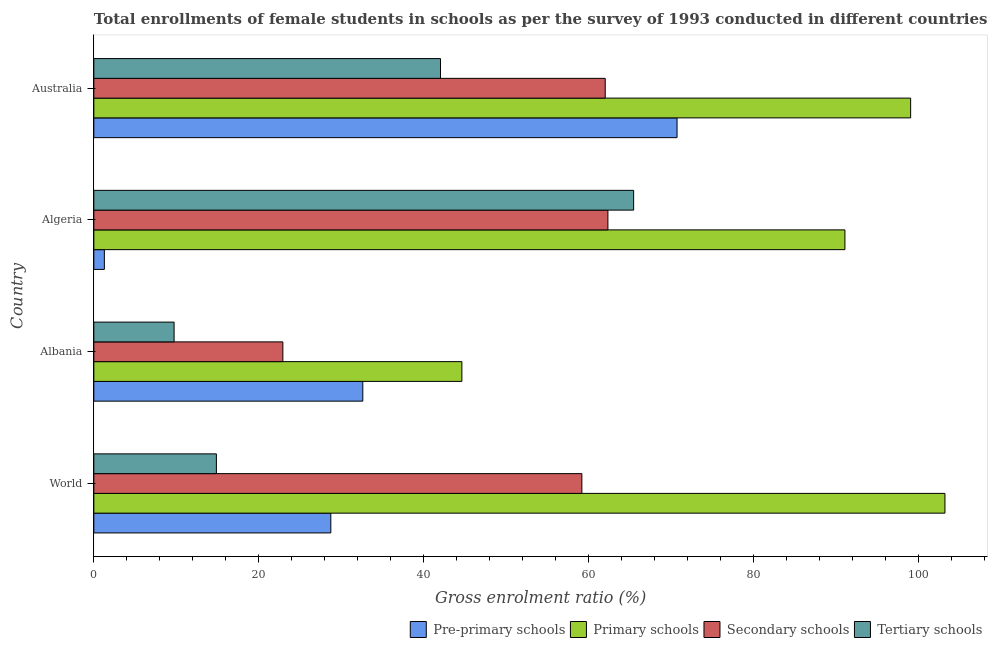How many groups of bars are there?
Keep it short and to the point. 4. Are the number of bars per tick equal to the number of legend labels?
Your response must be concise. Yes. How many bars are there on the 2nd tick from the top?
Provide a short and direct response. 4. What is the label of the 2nd group of bars from the top?
Keep it short and to the point. Algeria. What is the gross enrolment ratio(female) in secondary schools in Australia?
Provide a succinct answer. 62. Across all countries, what is the maximum gross enrolment ratio(female) in secondary schools?
Your answer should be very brief. 62.33. Across all countries, what is the minimum gross enrolment ratio(female) in primary schools?
Your answer should be very brief. 44.62. In which country was the gross enrolment ratio(female) in pre-primary schools maximum?
Offer a very short reply. Australia. In which country was the gross enrolment ratio(female) in tertiary schools minimum?
Your response must be concise. Albania. What is the total gross enrolment ratio(female) in secondary schools in the graph?
Provide a short and direct response. 206.42. What is the difference between the gross enrolment ratio(female) in secondary schools in Albania and that in Australia?
Keep it short and to the point. -39.08. What is the difference between the gross enrolment ratio(female) in tertiary schools in World and the gross enrolment ratio(female) in secondary schools in Albania?
Offer a very short reply. -8.06. What is the average gross enrolment ratio(female) in secondary schools per country?
Your response must be concise. 51.6. What is the ratio of the gross enrolment ratio(female) in tertiary schools in Algeria to that in World?
Give a very brief answer. 4.4. Is the difference between the gross enrolment ratio(female) in primary schools in Algeria and Australia greater than the difference between the gross enrolment ratio(female) in pre-primary schools in Algeria and Australia?
Give a very brief answer. Yes. What is the difference between the highest and the second highest gross enrolment ratio(female) in tertiary schools?
Ensure brevity in your answer.  23.42. What is the difference between the highest and the lowest gross enrolment ratio(female) in secondary schools?
Your response must be concise. 39.41. Is the sum of the gross enrolment ratio(female) in tertiary schools in Algeria and World greater than the maximum gross enrolment ratio(female) in pre-primary schools across all countries?
Offer a terse response. Yes. Is it the case that in every country, the sum of the gross enrolment ratio(female) in primary schools and gross enrolment ratio(female) in secondary schools is greater than the sum of gross enrolment ratio(female) in pre-primary schools and gross enrolment ratio(female) in tertiary schools?
Keep it short and to the point. No. What does the 1st bar from the top in World represents?
Your answer should be compact. Tertiary schools. What does the 2nd bar from the bottom in Albania represents?
Provide a short and direct response. Primary schools. How many bars are there?
Keep it short and to the point. 16. Are all the bars in the graph horizontal?
Keep it short and to the point. Yes. What is the difference between two consecutive major ticks on the X-axis?
Make the answer very short. 20. Are the values on the major ticks of X-axis written in scientific E-notation?
Offer a very short reply. No. Does the graph contain grids?
Make the answer very short. No. How many legend labels are there?
Provide a short and direct response. 4. How are the legend labels stacked?
Your answer should be very brief. Horizontal. What is the title of the graph?
Your response must be concise. Total enrollments of female students in schools as per the survey of 1993 conducted in different countries. What is the label or title of the X-axis?
Provide a short and direct response. Gross enrolment ratio (%). What is the label or title of the Y-axis?
Offer a terse response. Country. What is the Gross enrolment ratio (%) in Pre-primary schools in World?
Make the answer very short. 28.73. What is the Gross enrolment ratio (%) in Primary schools in World?
Ensure brevity in your answer.  103.19. What is the Gross enrolment ratio (%) in Secondary schools in World?
Keep it short and to the point. 59.17. What is the Gross enrolment ratio (%) of Tertiary schools in World?
Ensure brevity in your answer.  14.86. What is the Gross enrolment ratio (%) in Pre-primary schools in Albania?
Ensure brevity in your answer.  32.61. What is the Gross enrolment ratio (%) of Primary schools in Albania?
Offer a terse response. 44.62. What is the Gross enrolment ratio (%) of Secondary schools in Albania?
Offer a very short reply. 22.92. What is the Gross enrolment ratio (%) of Tertiary schools in Albania?
Provide a short and direct response. 9.73. What is the Gross enrolment ratio (%) in Pre-primary schools in Algeria?
Your response must be concise. 1.28. What is the Gross enrolment ratio (%) of Primary schools in Algeria?
Ensure brevity in your answer.  91.06. What is the Gross enrolment ratio (%) of Secondary schools in Algeria?
Provide a short and direct response. 62.33. What is the Gross enrolment ratio (%) in Tertiary schools in Algeria?
Make the answer very short. 65.45. What is the Gross enrolment ratio (%) in Pre-primary schools in Australia?
Your answer should be compact. 70.71. What is the Gross enrolment ratio (%) in Primary schools in Australia?
Make the answer very short. 99.03. What is the Gross enrolment ratio (%) of Secondary schools in Australia?
Provide a short and direct response. 62. What is the Gross enrolment ratio (%) in Tertiary schools in Australia?
Your answer should be very brief. 42.03. Across all countries, what is the maximum Gross enrolment ratio (%) of Pre-primary schools?
Offer a very short reply. 70.71. Across all countries, what is the maximum Gross enrolment ratio (%) in Primary schools?
Give a very brief answer. 103.19. Across all countries, what is the maximum Gross enrolment ratio (%) in Secondary schools?
Offer a terse response. 62.33. Across all countries, what is the maximum Gross enrolment ratio (%) in Tertiary schools?
Your answer should be very brief. 65.45. Across all countries, what is the minimum Gross enrolment ratio (%) of Pre-primary schools?
Your response must be concise. 1.28. Across all countries, what is the minimum Gross enrolment ratio (%) in Primary schools?
Keep it short and to the point. 44.62. Across all countries, what is the minimum Gross enrolment ratio (%) of Secondary schools?
Make the answer very short. 22.92. Across all countries, what is the minimum Gross enrolment ratio (%) of Tertiary schools?
Give a very brief answer. 9.73. What is the total Gross enrolment ratio (%) in Pre-primary schools in the graph?
Provide a short and direct response. 133.33. What is the total Gross enrolment ratio (%) of Primary schools in the graph?
Offer a very short reply. 337.91. What is the total Gross enrolment ratio (%) in Secondary schools in the graph?
Provide a short and direct response. 206.42. What is the total Gross enrolment ratio (%) of Tertiary schools in the graph?
Offer a terse response. 132.07. What is the difference between the Gross enrolment ratio (%) in Pre-primary schools in World and that in Albania?
Offer a very short reply. -3.88. What is the difference between the Gross enrolment ratio (%) of Primary schools in World and that in Albania?
Ensure brevity in your answer.  58.57. What is the difference between the Gross enrolment ratio (%) of Secondary schools in World and that in Albania?
Provide a succinct answer. 36.25. What is the difference between the Gross enrolment ratio (%) in Tertiary schools in World and that in Albania?
Make the answer very short. 5.13. What is the difference between the Gross enrolment ratio (%) of Pre-primary schools in World and that in Algeria?
Give a very brief answer. 27.45. What is the difference between the Gross enrolment ratio (%) in Primary schools in World and that in Algeria?
Your response must be concise. 12.13. What is the difference between the Gross enrolment ratio (%) in Secondary schools in World and that in Algeria?
Give a very brief answer. -3.16. What is the difference between the Gross enrolment ratio (%) in Tertiary schools in World and that in Algeria?
Give a very brief answer. -50.59. What is the difference between the Gross enrolment ratio (%) in Pre-primary schools in World and that in Australia?
Your answer should be compact. -41.98. What is the difference between the Gross enrolment ratio (%) of Primary schools in World and that in Australia?
Offer a very short reply. 4.16. What is the difference between the Gross enrolment ratio (%) in Secondary schools in World and that in Australia?
Ensure brevity in your answer.  -2.83. What is the difference between the Gross enrolment ratio (%) in Tertiary schools in World and that in Australia?
Give a very brief answer. -27.17. What is the difference between the Gross enrolment ratio (%) in Pre-primary schools in Albania and that in Algeria?
Keep it short and to the point. 31.33. What is the difference between the Gross enrolment ratio (%) in Primary schools in Albania and that in Algeria?
Offer a very short reply. -46.44. What is the difference between the Gross enrolment ratio (%) in Secondary schools in Albania and that in Algeria?
Keep it short and to the point. -39.41. What is the difference between the Gross enrolment ratio (%) in Tertiary schools in Albania and that in Algeria?
Offer a very short reply. -55.72. What is the difference between the Gross enrolment ratio (%) of Pre-primary schools in Albania and that in Australia?
Your answer should be compact. -38.1. What is the difference between the Gross enrolment ratio (%) of Primary schools in Albania and that in Australia?
Your response must be concise. -54.41. What is the difference between the Gross enrolment ratio (%) of Secondary schools in Albania and that in Australia?
Make the answer very short. -39.08. What is the difference between the Gross enrolment ratio (%) of Tertiary schools in Albania and that in Australia?
Your answer should be very brief. -32.3. What is the difference between the Gross enrolment ratio (%) of Pre-primary schools in Algeria and that in Australia?
Provide a short and direct response. -69.43. What is the difference between the Gross enrolment ratio (%) of Primary schools in Algeria and that in Australia?
Offer a terse response. -7.97. What is the difference between the Gross enrolment ratio (%) of Secondary schools in Algeria and that in Australia?
Give a very brief answer. 0.33. What is the difference between the Gross enrolment ratio (%) in Tertiary schools in Algeria and that in Australia?
Ensure brevity in your answer.  23.42. What is the difference between the Gross enrolment ratio (%) in Pre-primary schools in World and the Gross enrolment ratio (%) in Primary schools in Albania?
Your answer should be very brief. -15.89. What is the difference between the Gross enrolment ratio (%) of Pre-primary schools in World and the Gross enrolment ratio (%) of Secondary schools in Albania?
Provide a succinct answer. 5.81. What is the difference between the Gross enrolment ratio (%) in Pre-primary schools in World and the Gross enrolment ratio (%) in Tertiary schools in Albania?
Give a very brief answer. 19. What is the difference between the Gross enrolment ratio (%) in Primary schools in World and the Gross enrolment ratio (%) in Secondary schools in Albania?
Your response must be concise. 80.27. What is the difference between the Gross enrolment ratio (%) in Primary schools in World and the Gross enrolment ratio (%) in Tertiary schools in Albania?
Your answer should be very brief. 93.46. What is the difference between the Gross enrolment ratio (%) of Secondary schools in World and the Gross enrolment ratio (%) of Tertiary schools in Albania?
Provide a short and direct response. 49.44. What is the difference between the Gross enrolment ratio (%) of Pre-primary schools in World and the Gross enrolment ratio (%) of Primary schools in Algeria?
Ensure brevity in your answer.  -62.33. What is the difference between the Gross enrolment ratio (%) of Pre-primary schools in World and the Gross enrolment ratio (%) of Secondary schools in Algeria?
Offer a terse response. -33.59. What is the difference between the Gross enrolment ratio (%) in Pre-primary schools in World and the Gross enrolment ratio (%) in Tertiary schools in Algeria?
Provide a succinct answer. -36.71. What is the difference between the Gross enrolment ratio (%) in Primary schools in World and the Gross enrolment ratio (%) in Secondary schools in Algeria?
Provide a short and direct response. 40.86. What is the difference between the Gross enrolment ratio (%) of Primary schools in World and the Gross enrolment ratio (%) of Tertiary schools in Algeria?
Offer a terse response. 37.74. What is the difference between the Gross enrolment ratio (%) in Secondary schools in World and the Gross enrolment ratio (%) in Tertiary schools in Algeria?
Make the answer very short. -6.28. What is the difference between the Gross enrolment ratio (%) of Pre-primary schools in World and the Gross enrolment ratio (%) of Primary schools in Australia?
Provide a succinct answer. -70.3. What is the difference between the Gross enrolment ratio (%) of Pre-primary schools in World and the Gross enrolment ratio (%) of Secondary schools in Australia?
Ensure brevity in your answer.  -33.27. What is the difference between the Gross enrolment ratio (%) of Pre-primary schools in World and the Gross enrolment ratio (%) of Tertiary schools in Australia?
Your answer should be very brief. -13.3. What is the difference between the Gross enrolment ratio (%) of Primary schools in World and the Gross enrolment ratio (%) of Secondary schools in Australia?
Give a very brief answer. 41.19. What is the difference between the Gross enrolment ratio (%) of Primary schools in World and the Gross enrolment ratio (%) of Tertiary schools in Australia?
Provide a short and direct response. 61.16. What is the difference between the Gross enrolment ratio (%) of Secondary schools in World and the Gross enrolment ratio (%) of Tertiary schools in Australia?
Your answer should be very brief. 17.14. What is the difference between the Gross enrolment ratio (%) of Pre-primary schools in Albania and the Gross enrolment ratio (%) of Primary schools in Algeria?
Give a very brief answer. -58.45. What is the difference between the Gross enrolment ratio (%) of Pre-primary schools in Albania and the Gross enrolment ratio (%) of Secondary schools in Algeria?
Your answer should be compact. -29.72. What is the difference between the Gross enrolment ratio (%) of Pre-primary schools in Albania and the Gross enrolment ratio (%) of Tertiary schools in Algeria?
Provide a succinct answer. -32.84. What is the difference between the Gross enrolment ratio (%) in Primary schools in Albania and the Gross enrolment ratio (%) in Secondary schools in Algeria?
Your answer should be very brief. -17.7. What is the difference between the Gross enrolment ratio (%) of Primary schools in Albania and the Gross enrolment ratio (%) of Tertiary schools in Algeria?
Your answer should be compact. -20.82. What is the difference between the Gross enrolment ratio (%) in Secondary schools in Albania and the Gross enrolment ratio (%) in Tertiary schools in Algeria?
Make the answer very short. -42.53. What is the difference between the Gross enrolment ratio (%) of Pre-primary schools in Albania and the Gross enrolment ratio (%) of Primary schools in Australia?
Offer a terse response. -66.42. What is the difference between the Gross enrolment ratio (%) of Pre-primary schools in Albania and the Gross enrolment ratio (%) of Secondary schools in Australia?
Your answer should be very brief. -29.39. What is the difference between the Gross enrolment ratio (%) of Pre-primary schools in Albania and the Gross enrolment ratio (%) of Tertiary schools in Australia?
Provide a short and direct response. -9.42. What is the difference between the Gross enrolment ratio (%) of Primary schools in Albania and the Gross enrolment ratio (%) of Secondary schools in Australia?
Keep it short and to the point. -17.38. What is the difference between the Gross enrolment ratio (%) of Primary schools in Albania and the Gross enrolment ratio (%) of Tertiary schools in Australia?
Provide a short and direct response. 2.59. What is the difference between the Gross enrolment ratio (%) in Secondary schools in Albania and the Gross enrolment ratio (%) in Tertiary schools in Australia?
Provide a succinct answer. -19.11. What is the difference between the Gross enrolment ratio (%) in Pre-primary schools in Algeria and the Gross enrolment ratio (%) in Primary schools in Australia?
Keep it short and to the point. -97.75. What is the difference between the Gross enrolment ratio (%) of Pre-primary schools in Algeria and the Gross enrolment ratio (%) of Secondary schools in Australia?
Your response must be concise. -60.72. What is the difference between the Gross enrolment ratio (%) in Pre-primary schools in Algeria and the Gross enrolment ratio (%) in Tertiary schools in Australia?
Make the answer very short. -40.75. What is the difference between the Gross enrolment ratio (%) of Primary schools in Algeria and the Gross enrolment ratio (%) of Secondary schools in Australia?
Provide a succinct answer. 29.06. What is the difference between the Gross enrolment ratio (%) of Primary schools in Algeria and the Gross enrolment ratio (%) of Tertiary schools in Australia?
Give a very brief answer. 49.03. What is the difference between the Gross enrolment ratio (%) in Secondary schools in Algeria and the Gross enrolment ratio (%) in Tertiary schools in Australia?
Make the answer very short. 20.3. What is the average Gross enrolment ratio (%) in Pre-primary schools per country?
Give a very brief answer. 33.33. What is the average Gross enrolment ratio (%) in Primary schools per country?
Provide a succinct answer. 84.48. What is the average Gross enrolment ratio (%) of Secondary schools per country?
Your answer should be very brief. 51.6. What is the average Gross enrolment ratio (%) of Tertiary schools per country?
Give a very brief answer. 33.02. What is the difference between the Gross enrolment ratio (%) in Pre-primary schools and Gross enrolment ratio (%) in Primary schools in World?
Provide a short and direct response. -74.46. What is the difference between the Gross enrolment ratio (%) of Pre-primary schools and Gross enrolment ratio (%) of Secondary schools in World?
Provide a succinct answer. -30.44. What is the difference between the Gross enrolment ratio (%) of Pre-primary schools and Gross enrolment ratio (%) of Tertiary schools in World?
Give a very brief answer. 13.87. What is the difference between the Gross enrolment ratio (%) in Primary schools and Gross enrolment ratio (%) in Secondary schools in World?
Your answer should be very brief. 44.02. What is the difference between the Gross enrolment ratio (%) in Primary schools and Gross enrolment ratio (%) in Tertiary schools in World?
Your response must be concise. 88.33. What is the difference between the Gross enrolment ratio (%) in Secondary schools and Gross enrolment ratio (%) in Tertiary schools in World?
Keep it short and to the point. 44.31. What is the difference between the Gross enrolment ratio (%) of Pre-primary schools and Gross enrolment ratio (%) of Primary schools in Albania?
Ensure brevity in your answer.  -12.01. What is the difference between the Gross enrolment ratio (%) of Pre-primary schools and Gross enrolment ratio (%) of Secondary schools in Albania?
Your answer should be very brief. 9.69. What is the difference between the Gross enrolment ratio (%) in Pre-primary schools and Gross enrolment ratio (%) in Tertiary schools in Albania?
Give a very brief answer. 22.88. What is the difference between the Gross enrolment ratio (%) in Primary schools and Gross enrolment ratio (%) in Secondary schools in Albania?
Provide a short and direct response. 21.7. What is the difference between the Gross enrolment ratio (%) of Primary schools and Gross enrolment ratio (%) of Tertiary schools in Albania?
Offer a terse response. 34.89. What is the difference between the Gross enrolment ratio (%) in Secondary schools and Gross enrolment ratio (%) in Tertiary schools in Albania?
Keep it short and to the point. 13.19. What is the difference between the Gross enrolment ratio (%) of Pre-primary schools and Gross enrolment ratio (%) of Primary schools in Algeria?
Your answer should be compact. -89.79. What is the difference between the Gross enrolment ratio (%) in Pre-primary schools and Gross enrolment ratio (%) in Secondary schools in Algeria?
Your answer should be compact. -61.05. What is the difference between the Gross enrolment ratio (%) in Pre-primary schools and Gross enrolment ratio (%) in Tertiary schools in Algeria?
Make the answer very short. -64.17. What is the difference between the Gross enrolment ratio (%) in Primary schools and Gross enrolment ratio (%) in Secondary schools in Algeria?
Provide a short and direct response. 28.74. What is the difference between the Gross enrolment ratio (%) of Primary schools and Gross enrolment ratio (%) of Tertiary schools in Algeria?
Your answer should be very brief. 25.62. What is the difference between the Gross enrolment ratio (%) in Secondary schools and Gross enrolment ratio (%) in Tertiary schools in Algeria?
Your answer should be very brief. -3.12. What is the difference between the Gross enrolment ratio (%) of Pre-primary schools and Gross enrolment ratio (%) of Primary schools in Australia?
Ensure brevity in your answer.  -28.32. What is the difference between the Gross enrolment ratio (%) of Pre-primary schools and Gross enrolment ratio (%) of Secondary schools in Australia?
Offer a very short reply. 8.71. What is the difference between the Gross enrolment ratio (%) in Pre-primary schools and Gross enrolment ratio (%) in Tertiary schools in Australia?
Offer a very short reply. 28.68. What is the difference between the Gross enrolment ratio (%) in Primary schools and Gross enrolment ratio (%) in Secondary schools in Australia?
Provide a succinct answer. 37.03. What is the difference between the Gross enrolment ratio (%) of Primary schools and Gross enrolment ratio (%) of Tertiary schools in Australia?
Provide a succinct answer. 57. What is the difference between the Gross enrolment ratio (%) in Secondary schools and Gross enrolment ratio (%) in Tertiary schools in Australia?
Provide a succinct answer. 19.97. What is the ratio of the Gross enrolment ratio (%) in Pre-primary schools in World to that in Albania?
Your answer should be very brief. 0.88. What is the ratio of the Gross enrolment ratio (%) in Primary schools in World to that in Albania?
Provide a short and direct response. 2.31. What is the ratio of the Gross enrolment ratio (%) in Secondary schools in World to that in Albania?
Offer a terse response. 2.58. What is the ratio of the Gross enrolment ratio (%) in Tertiary schools in World to that in Albania?
Offer a terse response. 1.53. What is the ratio of the Gross enrolment ratio (%) in Pre-primary schools in World to that in Algeria?
Your answer should be compact. 22.48. What is the ratio of the Gross enrolment ratio (%) of Primary schools in World to that in Algeria?
Keep it short and to the point. 1.13. What is the ratio of the Gross enrolment ratio (%) in Secondary schools in World to that in Algeria?
Your response must be concise. 0.95. What is the ratio of the Gross enrolment ratio (%) in Tertiary schools in World to that in Algeria?
Ensure brevity in your answer.  0.23. What is the ratio of the Gross enrolment ratio (%) in Pre-primary schools in World to that in Australia?
Make the answer very short. 0.41. What is the ratio of the Gross enrolment ratio (%) of Primary schools in World to that in Australia?
Keep it short and to the point. 1.04. What is the ratio of the Gross enrolment ratio (%) of Secondary schools in World to that in Australia?
Give a very brief answer. 0.95. What is the ratio of the Gross enrolment ratio (%) in Tertiary schools in World to that in Australia?
Your answer should be compact. 0.35. What is the ratio of the Gross enrolment ratio (%) of Pre-primary schools in Albania to that in Algeria?
Provide a short and direct response. 25.51. What is the ratio of the Gross enrolment ratio (%) of Primary schools in Albania to that in Algeria?
Offer a terse response. 0.49. What is the ratio of the Gross enrolment ratio (%) of Secondary schools in Albania to that in Algeria?
Give a very brief answer. 0.37. What is the ratio of the Gross enrolment ratio (%) in Tertiary schools in Albania to that in Algeria?
Provide a short and direct response. 0.15. What is the ratio of the Gross enrolment ratio (%) in Pre-primary schools in Albania to that in Australia?
Your answer should be very brief. 0.46. What is the ratio of the Gross enrolment ratio (%) in Primary schools in Albania to that in Australia?
Offer a terse response. 0.45. What is the ratio of the Gross enrolment ratio (%) of Secondary schools in Albania to that in Australia?
Keep it short and to the point. 0.37. What is the ratio of the Gross enrolment ratio (%) of Tertiary schools in Albania to that in Australia?
Provide a short and direct response. 0.23. What is the ratio of the Gross enrolment ratio (%) of Pre-primary schools in Algeria to that in Australia?
Offer a very short reply. 0.02. What is the ratio of the Gross enrolment ratio (%) of Primary schools in Algeria to that in Australia?
Ensure brevity in your answer.  0.92. What is the ratio of the Gross enrolment ratio (%) of Tertiary schools in Algeria to that in Australia?
Make the answer very short. 1.56. What is the difference between the highest and the second highest Gross enrolment ratio (%) of Pre-primary schools?
Provide a short and direct response. 38.1. What is the difference between the highest and the second highest Gross enrolment ratio (%) of Primary schools?
Your answer should be very brief. 4.16. What is the difference between the highest and the second highest Gross enrolment ratio (%) in Secondary schools?
Your answer should be compact. 0.33. What is the difference between the highest and the second highest Gross enrolment ratio (%) in Tertiary schools?
Provide a succinct answer. 23.42. What is the difference between the highest and the lowest Gross enrolment ratio (%) of Pre-primary schools?
Provide a succinct answer. 69.43. What is the difference between the highest and the lowest Gross enrolment ratio (%) in Primary schools?
Ensure brevity in your answer.  58.57. What is the difference between the highest and the lowest Gross enrolment ratio (%) of Secondary schools?
Your response must be concise. 39.41. What is the difference between the highest and the lowest Gross enrolment ratio (%) of Tertiary schools?
Your response must be concise. 55.72. 